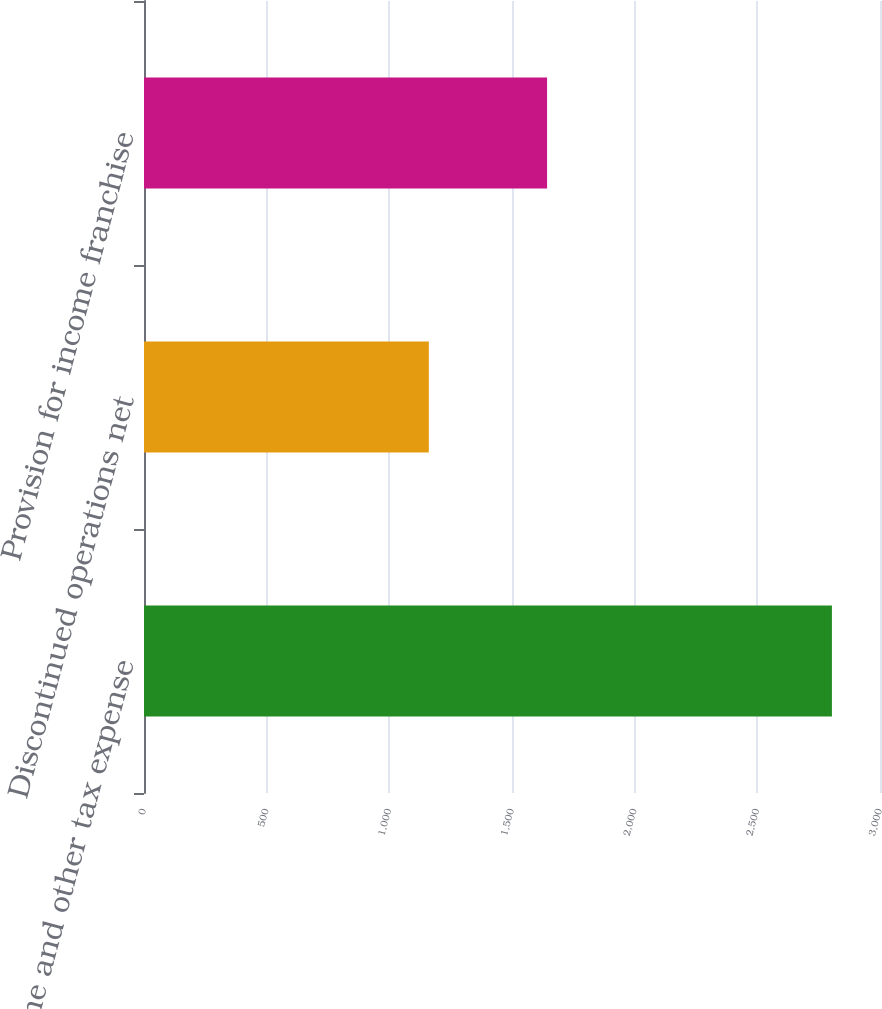Convert chart to OTSL. <chart><loc_0><loc_0><loc_500><loc_500><bar_chart><fcel>Income and other tax expense<fcel>Discontinued operations net<fcel>Provision for income franchise<nl><fcel>2804<fcel>1161<fcel>1643<nl></chart> 